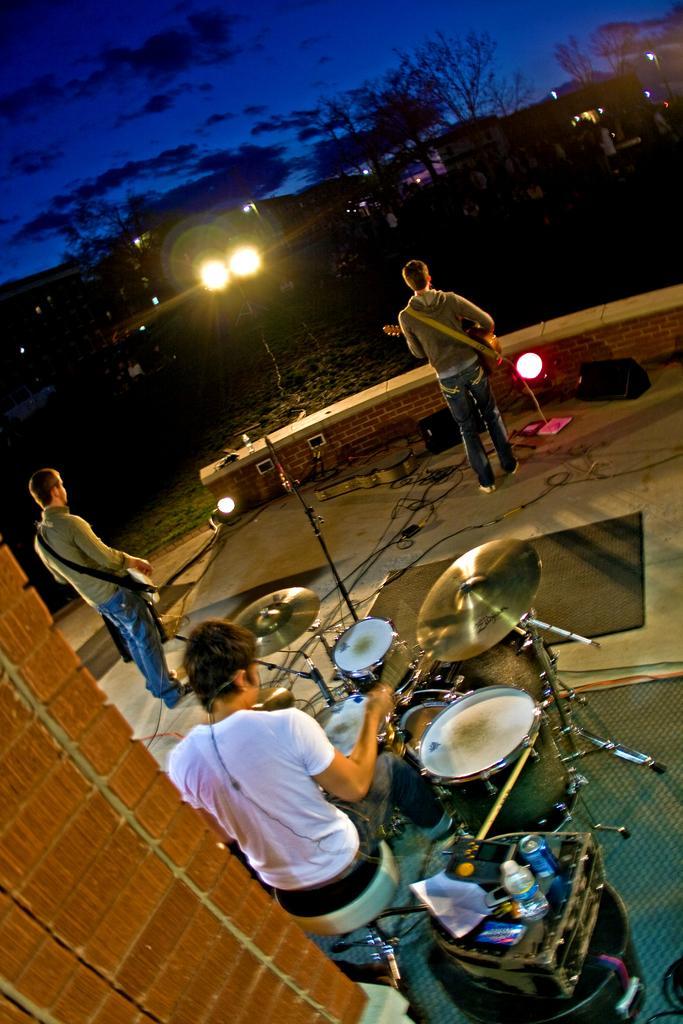How would you summarize this image in a sentence or two? In the image there is a man playing drum and in the front there is another guy playing guitar on left side and other guy playing guitar and the sky full of clouds it's dark ,there is a vehicle with lights on the front. 